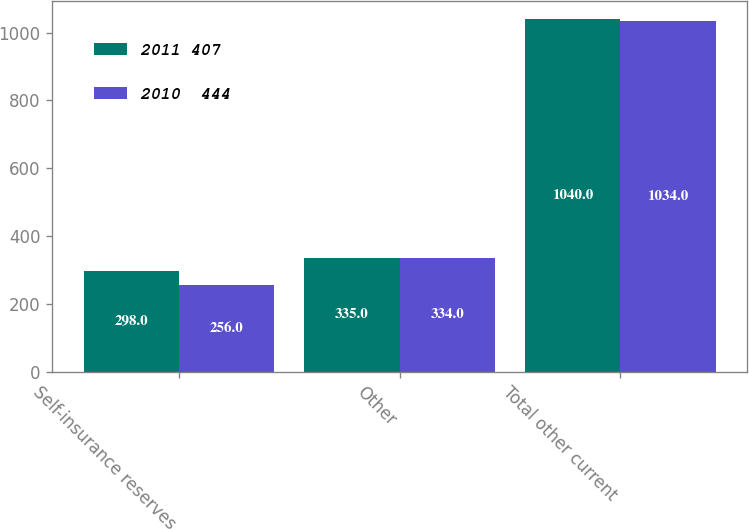Convert chart. <chart><loc_0><loc_0><loc_500><loc_500><stacked_bar_chart><ecel><fcel>Self-insurance reserves<fcel>Other<fcel>Total other current<nl><fcel>2011 407<fcel>298<fcel>335<fcel>1040<nl><fcel>2010  444<fcel>256<fcel>334<fcel>1034<nl></chart> 